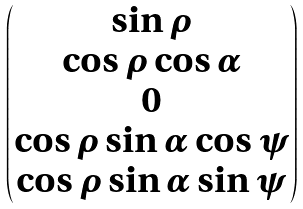Convert formula to latex. <formula><loc_0><loc_0><loc_500><loc_500>\begin{pmatrix} \sin \rho \\ \cos \rho \cos \alpha \\ 0 \\ \cos \rho \sin \alpha \cos \psi \\ \cos \rho \sin \alpha \sin \psi \\ \end{pmatrix}</formula> 